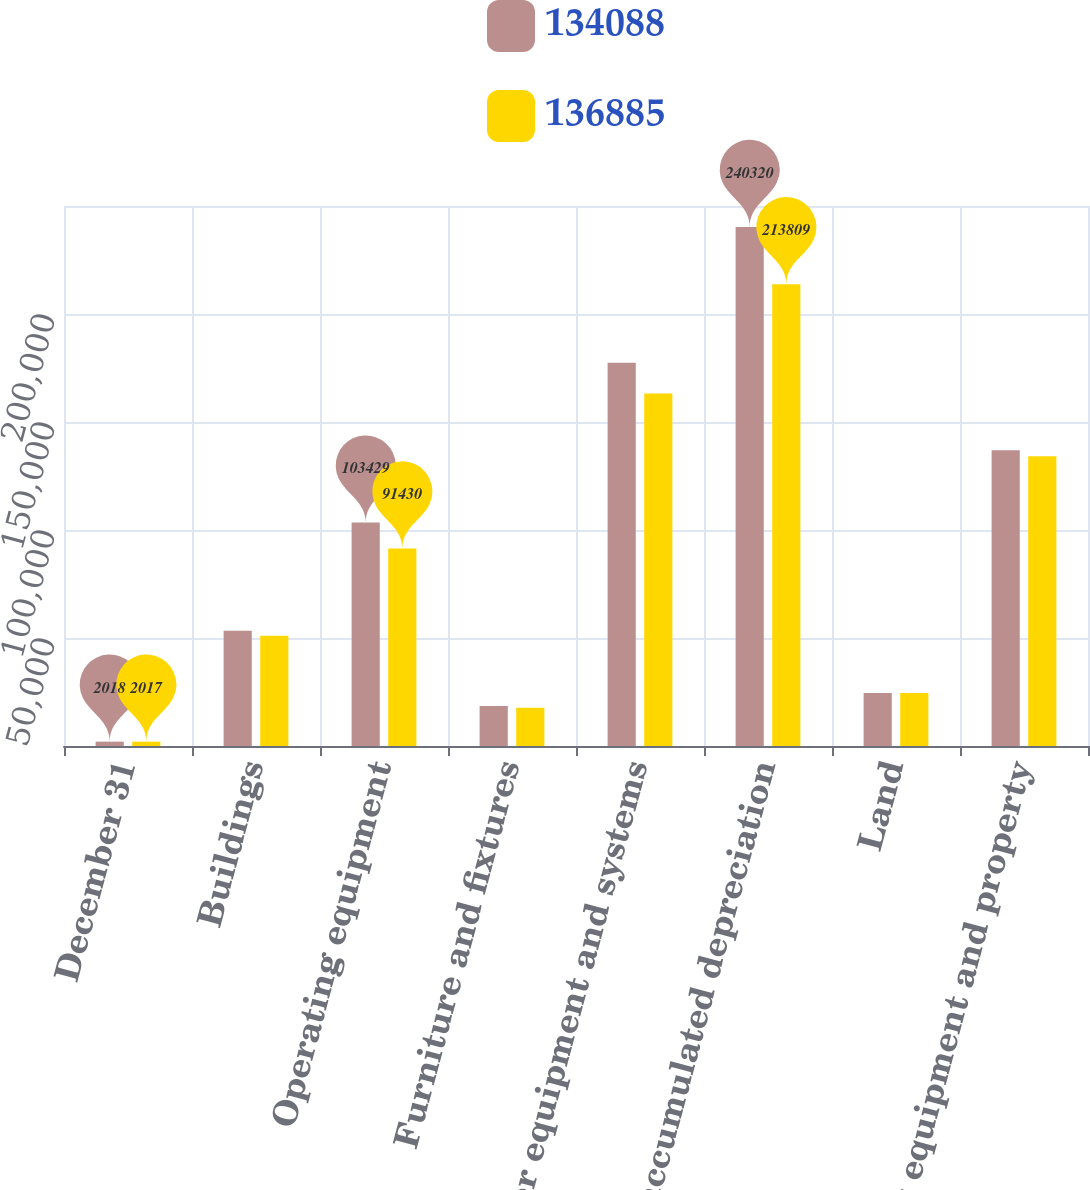Convert chart to OTSL. <chart><loc_0><loc_0><loc_500><loc_500><stacked_bar_chart><ecel><fcel>December 31<fcel>Buildings<fcel>Operating equipment<fcel>Furniture and fixtures<fcel>Computer equipment and systems<fcel>Less accumulated depreciation<fcel>Land<fcel>Net equipment and property<nl><fcel>134088<fcel>2018<fcel>53339<fcel>103429<fcel>18476<fcel>177441<fcel>240320<fcel>24520<fcel>136885<nl><fcel>136885<fcel>2017<fcel>51023<fcel>91430<fcel>17672<fcel>163220<fcel>213809<fcel>24552<fcel>134088<nl></chart> 